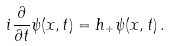<formula> <loc_0><loc_0><loc_500><loc_500>i \frac { \partial } { \partial t } \psi ( x , t ) = h _ { + } \psi ( x , t ) \, .</formula> 